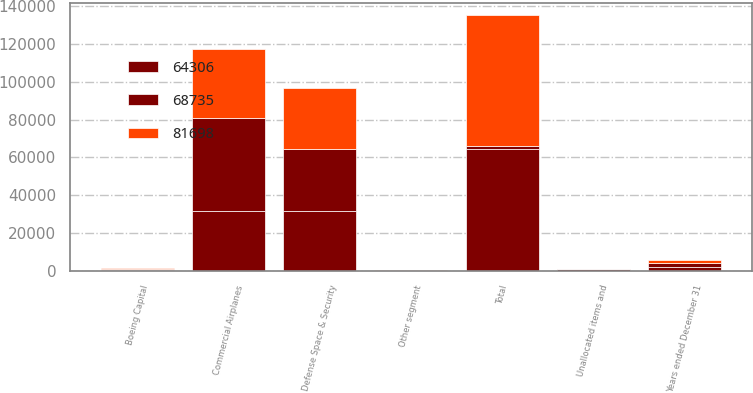<chart> <loc_0><loc_0><loc_500><loc_500><stacked_bar_chart><ecel><fcel>Years ended December 31<fcel>Commercial Airplanes<fcel>Defense Space & Security<fcel>Boeing Capital<fcel>Other segment<fcel>Unallocated items and<fcel>Total<nl><fcel>68735<fcel>2012<fcel>49127<fcel>32607<fcel>441<fcel>133<fcel>610<fcel>2010.5<nl><fcel>81698<fcel>2011<fcel>36171<fcel>31976<fcel>520<fcel>150<fcel>82<fcel>68735<nl><fcel>64306<fcel>2010<fcel>31834<fcel>31943<fcel>639<fcel>138<fcel>248<fcel>64306<nl></chart> 